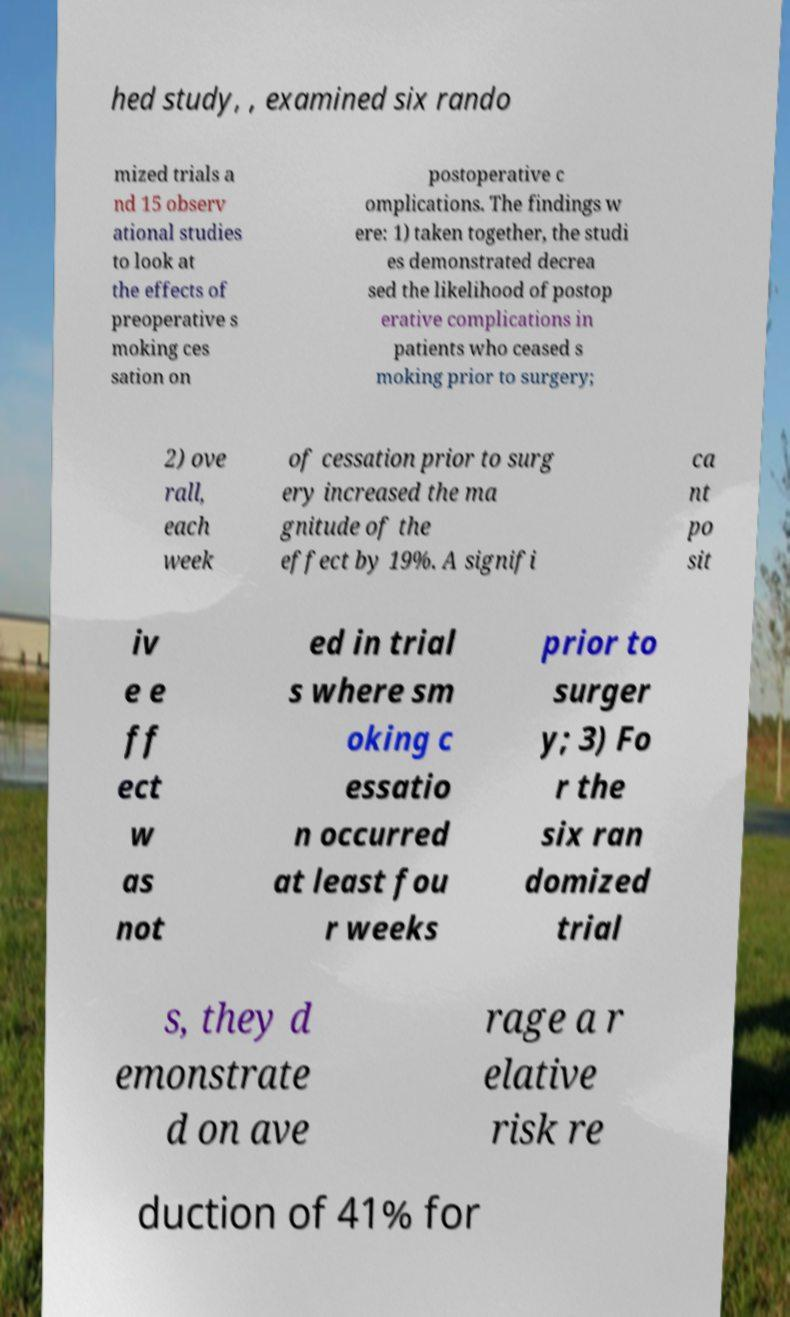Please identify and transcribe the text found in this image. hed study, , examined six rando mized trials a nd 15 observ ational studies to look at the effects of preoperative s moking ces sation on postoperative c omplications. The findings w ere: 1) taken together, the studi es demonstrated decrea sed the likelihood of postop erative complications in patients who ceased s moking prior to surgery; 2) ove rall, each week of cessation prior to surg ery increased the ma gnitude of the effect by 19%. A signifi ca nt po sit iv e e ff ect w as not ed in trial s where sm oking c essatio n occurred at least fou r weeks prior to surger y; 3) Fo r the six ran domized trial s, they d emonstrate d on ave rage a r elative risk re duction of 41% for 